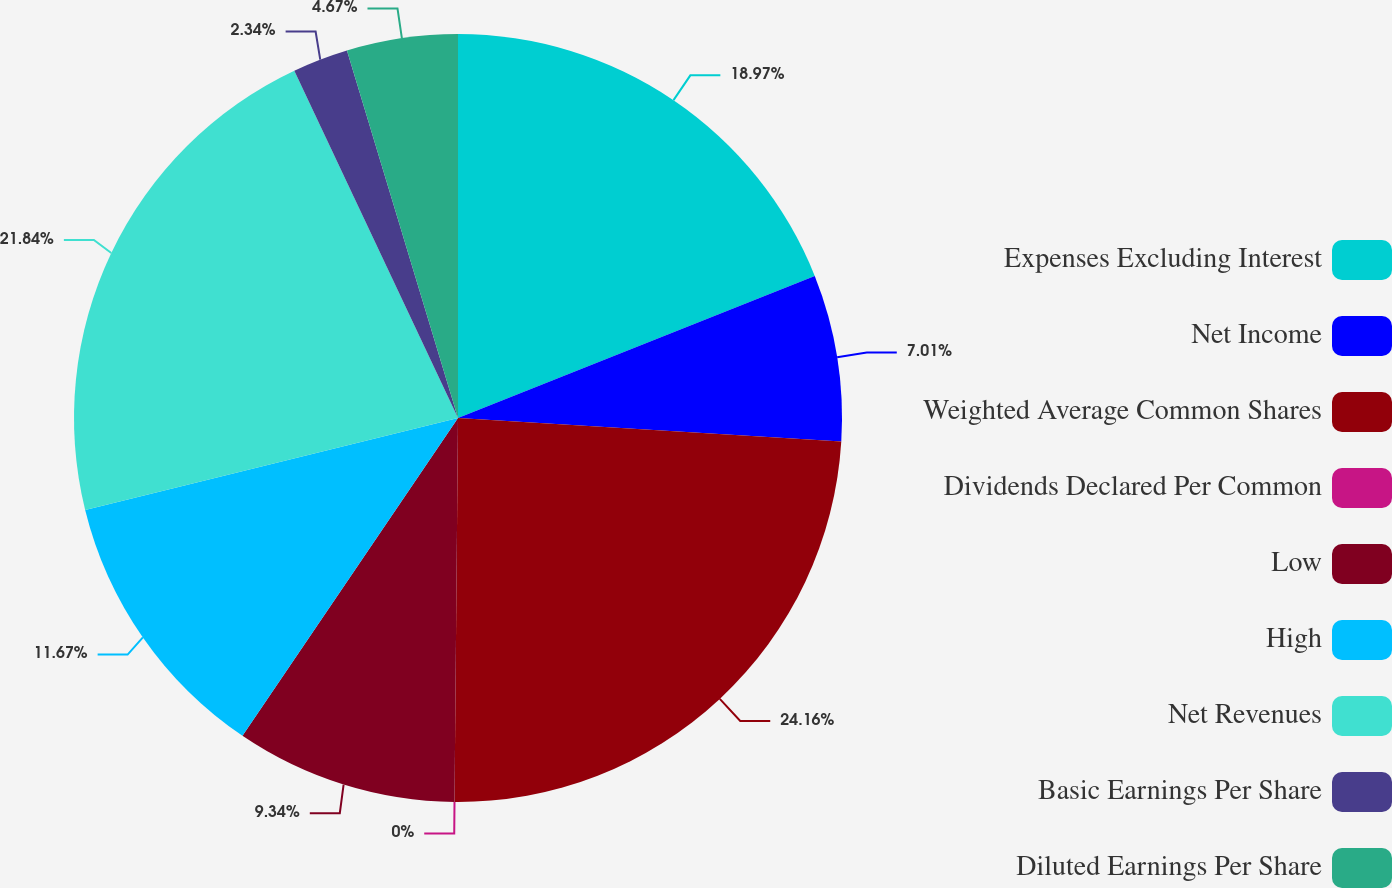Convert chart. <chart><loc_0><loc_0><loc_500><loc_500><pie_chart><fcel>Expenses Excluding Interest<fcel>Net Income<fcel>Weighted Average Common Shares<fcel>Dividends Declared Per Common<fcel>Low<fcel>High<fcel>Net Revenues<fcel>Basic Earnings Per Share<fcel>Diluted Earnings Per Share<nl><fcel>18.97%<fcel>7.01%<fcel>24.17%<fcel>0.0%<fcel>9.34%<fcel>11.67%<fcel>21.84%<fcel>2.34%<fcel>4.67%<nl></chart> 